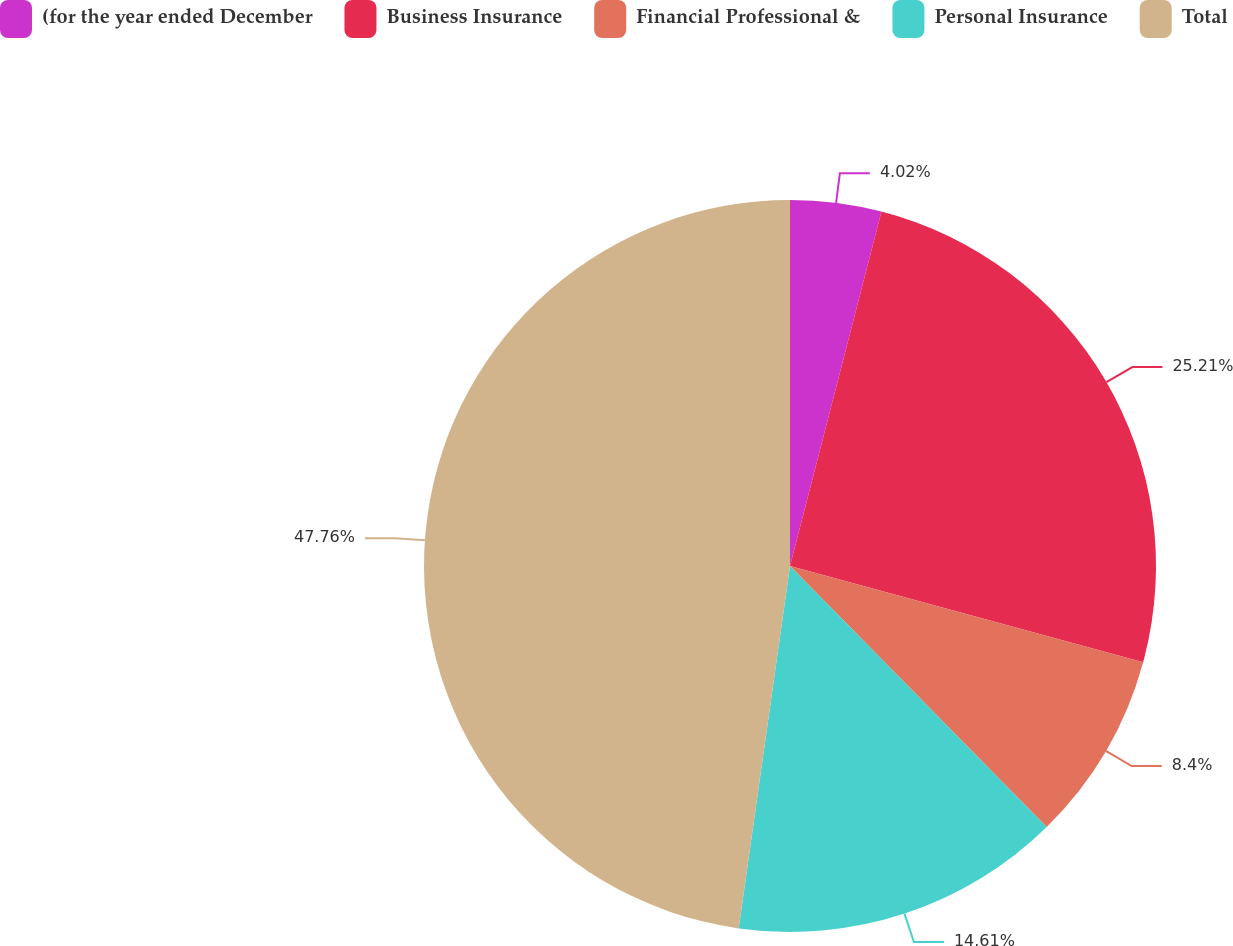<chart> <loc_0><loc_0><loc_500><loc_500><pie_chart><fcel>(for the year ended December<fcel>Business Insurance<fcel>Financial Professional &<fcel>Personal Insurance<fcel>Total<nl><fcel>4.02%<fcel>25.21%<fcel>8.4%<fcel>14.61%<fcel>47.76%<nl></chart> 